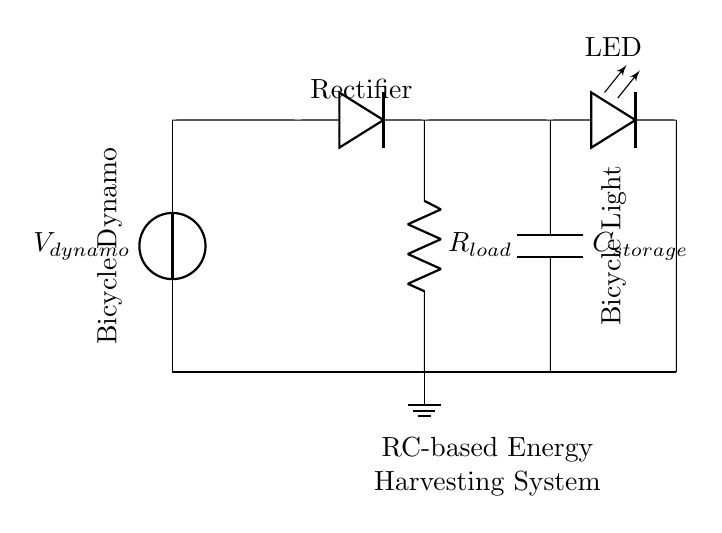What is the power source in this circuit? The power source is a bicycle dynamo, indicated by the voltage source labeled V_dynamo at the beginning of the circuit.
Answer: bicycle dynamo What component converts AC to DC? The component that converts AC to DC is a diode, shown in the circuit as a diode symbol between the voltage source and the RC circuit.
Answer: diode What does the capacitor store? The capacitor stores electrical energy from the dynamo when charged, which can then be used to power the bicycle light.
Answer: electrical energy What is the purpose of the resistor in this circuit? The resistor, labeled R_load, regulates the current flowing to the LED, protecting it from excessive current that may damage it.
Answer: current regulation What is the typical arrangement of components in an RC circuit? An RC circuit typically consists of a resistor and a capacitor arranged in series or parallel; in this case, they are in series after the diode.
Answer: series What will happen if the capacitor is fully charged? If the capacitor is fully charged, it will no longer store additional energy, and the voltage across it will stabilize, leading to a steady output for the LED.
Answer: voltage stabilization 